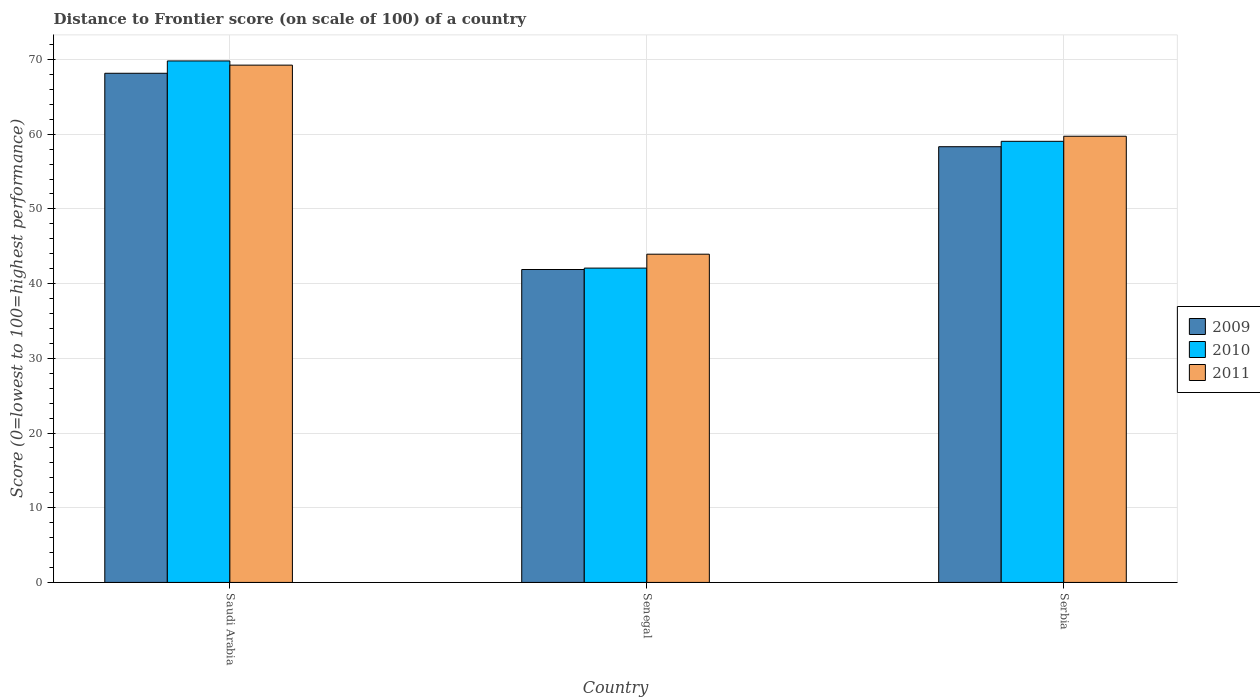How many groups of bars are there?
Offer a terse response. 3. Are the number of bars per tick equal to the number of legend labels?
Make the answer very short. Yes. Are the number of bars on each tick of the X-axis equal?
Offer a terse response. Yes. How many bars are there on the 2nd tick from the left?
Give a very brief answer. 3. How many bars are there on the 1st tick from the right?
Your answer should be very brief. 3. What is the label of the 1st group of bars from the left?
Your answer should be compact. Saudi Arabia. In how many cases, is the number of bars for a given country not equal to the number of legend labels?
Your answer should be compact. 0. What is the distance to frontier score of in 2010 in Senegal?
Provide a succinct answer. 42.08. Across all countries, what is the maximum distance to frontier score of in 2011?
Make the answer very short. 69.25. Across all countries, what is the minimum distance to frontier score of in 2009?
Make the answer very short. 41.89. In which country was the distance to frontier score of in 2009 maximum?
Provide a short and direct response. Saudi Arabia. In which country was the distance to frontier score of in 2010 minimum?
Keep it short and to the point. Senegal. What is the total distance to frontier score of in 2010 in the graph?
Your response must be concise. 170.94. What is the difference between the distance to frontier score of in 2010 in Saudi Arabia and that in Senegal?
Keep it short and to the point. 27.73. What is the difference between the distance to frontier score of in 2011 in Serbia and the distance to frontier score of in 2010 in Saudi Arabia?
Provide a short and direct response. -10.08. What is the average distance to frontier score of in 2011 per country?
Make the answer very short. 57.64. What is the difference between the distance to frontier score of of/in 2011 and distance to frontier score of of/in 2010 in Serbia?
Make the answer very short. 0.68. In how many countries, is the distance to frontier score of in 2010 greater than 36?
Ensure brevity in your answer.  3. What is the ratio of the distance to frontier score of in 2011 in Saudi Arabia to that in Serbia?
Give a very brief answer. 1.16. Is the difference between the distance to frontier score of in 2011 in Senegal and Serbia greater than the difference between the distance to frontier score of in 2010 in Senegal and Serbia?
Your response must be concise. Yes. What is the difference between the highest and the second highest distance to frontier score of in 2010?
Offer a very short reply. -16.97. What is the difference between the highest and the lowest distance to frontier score of in 2010?
Give a very brief answer. 27.73. Is the sum of the distance to frontier score of in 2011 in Saudi Arabia and Serbia greater than the maximum distance to frontier score of in 2010 across all countries?
Your response must be concise. Yes. What does the 3rd bar from the left in Serbia represents?
Your answer should be very brief. 2011. How many bars are there?
Offer a terse response. 9. Are all the bars in the graph horizontal?
Your answer should be compact. No. What is the difference between two consecutive major ticks on the Y-axis?
Ensure brevity in your answer.  10. Are the values on the major ticks of Y-axis written in scientific E-notation?
Provide a succinct answer. No. How many legend labels are there?
Your answer should be very brief. 3. How are the legend labels stacked?
Your answer should be very brief. Vertical. What is the title of the graph?
Offer a terse response. Distance to Frontier score (on scale of 100) of a country. Does "1960" appear as one of the legend labels in the graph?
Provide a short and direct response. No. What is the label or title of the X-axis?
Offer a very short reply. Country. What is the label or title of the Y-axis?
Provide a succinct answer. Score (0=lowest to 100=highest performance). What is the Score (0=lowest to 100=highest performance) of 2009 in Saudi Arabia?
Keep it short and to the point. 68.16. What is the Score (0=lowest to 100=highest performance) in 2010 in Saudi Arabia?
Ensure brevity in your answer.  69.81. What is the Score (0=lowest to 100=highest performance) in 2011 in Saudi Arabia?
Ensure brevity in your answer.  69.25. What is the Score (0=lowest to 100=highest performance) of 2009 in Senegal?
Provide a succinct answer. 41.89. What is the Score (0=lowest to 100=highest performance) in 2010 in Senegal?
Offer a terse response. 42.08. What is the Score (0=lowest to 100=highest performance) in 2011 in Senegal?
Ensure brevity in your answer.  43.94. What is the Score (0=lowest to 100=highest performance) in 2009 in Serbia?
Give a very brief answer. 58.33. What is the Score (0=lowest to 100=highest performance) of 2010 in Serbia?
Offer a terse response. 59.05. What is the Score (0=lowest to 100=highest performance) in 2011 in Serbia?
Offer a terse response. 59.73. Across all countries, what is the maximum Score (0=lowest to 100=highest performance) in 2009?
Provide a short and direct response. 68.16. Across all countries, what is the maximum Score (0=lowest to 100=highest performance) in 2010?
Make the answer very short. 69.81. Across all countries, what is the maximum Score (0=lowest to 100=highest performance) of 2011?
Your response must be concise. 69.25. Across all countries, what is the minimum Score (0=lowest to 100=highest performance) of 2009?
Keep it short and to the point. 41.89. Across all countries, what is the minimum Score (0=lowest to 100=highest performance) of 2010?
Your answer should be very brief. 42.08. Across all countries, what is the minimum Score (0=lowest to 100=highest performance) in 2011?
Make the answer very short. 43.94. What is the total Score (0=lowest to 100=highest performance) in 2009 in the graph?
Your answer should be very brief. 168.38. What is the total Score (0=lowest to 100=highest performance) in 2010 in the graph?
Keep it short and to the point. 170.94. What is the total Score (0=lowest to 100=highest performance) in 2011 in the graph?
Your answer should be compact. 172.92. What is the difference between the Score (0=lowest to 100=highest performance) in 2009 in Saudi Arabia and that in Senegal?
Provide a short and direct response. 26.27. What is the difference between the Score (0=lowest to 100=highest performance) in 2010 in Saudi Arabia and that in Senegal?
Provide a short and direct response. 27.73. What is the difference between the Score (0=lowest to 100=highest performance) in 2011 in Saudi Arabia and that in Senegal?
Your response must be concise. 25.31. What is the difference between the Score (0=lowest to 100=highest performance) of 2009 in Saudi Arabia and that in Serbia?
Ensure brevity in your answer.  9.83. What is the difference between the Score (0=lowest to 100=highest performance) in 2010 in Saudi Arabia and that in Serbia?
Give a very brief answer. 10.76. What is the difference between the Score (0=lowest to 100=highest performance) of 2011 in Saudi Arabia and that in Serbia?
Give a very brief answer. 9.52. What is the difference between the Score (0=lowest to 100=highest performance) of 2009 in Senegal and that in Serbia?
Your response must be concise. -16.44. What is the difference between the Score (0=lowest to 100=highest performance) in 2010 in Senegal and that in Serbia?
Keep it short and to the point. -16.97. What is the difference between the Score (0=lowest to 100=highest performance) of 2011 in Senegal and that in Serbia?
Give a very brief answer. -15.79. What is the difference between the Score (0=lowest to 100=highest performance) of 2009 in Saudi Arabia and the Score (0=lowest to 100=highest performance) of 2010 in Senegal?
Offer a terse response. 26.08. What is the difference between the Score (0=lowest to 100=highest performance) in 2009 in Saudi Arabia and the Score (0=lowest to 100=highest performance) in 2011 in Senegal?
Give a very brief answer. 24.22. What is the difference between the Score (0=lowest to 100=highest performance) in 2010 in Saudi Arabia and the Score (0=lowest to 100=highest performance) in 2011 in Senegal?
Your answer should be very brief. 25.87. What is the difference between the Score (0=lowest to 100=highest performance) of 2009 in Saudi Arabia and the Score (0=lowest to 100=highest performance) of 2010 in Serbia?
Offer a very short reply. 9.11. What is the difference between the Score (0=lowest to 100=highest performance) of 2009 in Saudi Arabia and the Score (0=lowest to 100=highest performance) of 2011 in Serbia?
Provide a short and direct response. 8.43. What is the difference between the Score (0=lowest to 100=highest performance) of 2010 in Saudi Arabia and the Score (0=lowest to 100=highest performance) of 2011 in Serbia?
Provide a short and direct response. 10.08. What is the difference between the Score (0=lowest to 100=highest performance) of 2009 in Senegal and the Score (0=lowest to 100=highest performance) of 2010 in Serbia?
Offer a terse response. -17.16. What is the difference between the Score (0=lowest to 100=highest performance) in 2009 in Senegal and the Score (0=lowest to 100=highest performance) in 2011 in Serbia?
Give a very brief answer. -17.84. What is the difference between the Score (0=lowest to 100=highest performance) in 2010 in Senegal and the Score (0=lowest to 100=highest performance) in 2011 in Serbia?
Your response must be concise. -17.65. What is the average Score (0=lowest to 100=highest performance) of 2009 per country?
Offer a very short reply. 56.13. What is the average Score (0=lowest to 100=highest performance) in 2010 per country?
Provide a succinct answer. 56.98. What is the average Score (0=lowest to 100=highest performance) of 2011 per country?
Provide a short and direct response. 57.64. What is the difference between the Score (0=lowest to 100=highest performance) of 2009 and Score (0=lowest to 100=highest performance) of 2010 in Saudi Arabia?
Your answer should be compact. -1.65. What is the difference between the Score (0=lowest to 100=highest performance) in 2009 and Score (0=lowest to 100=highest performance) in 2011 in Saudi Arabia?
Give a very brief answer. -1.09. What is the difference between the Score (0=lowest to 100=highest performance) of 2010 and Score (0=lowest to 100=highest performance) of 2011 in Saudi Arabia?
Give a very brief answer. 0.56. What is the difference between the Score (0=lowest to 100=highest performance) of 2009 and Score (0=lowest to 100=highest performance) of 2010 in Senegal?
Give a very brief answer. -0.19. What is the difference between the Score (0=lowest to 100=highest performance) in 2009 and Score (0=lowest to 100=highest performance) in 2011 in Senegal?
Offer a very short reply. -2.05. What is the difference between the Score (0=lowest to 100=highest performance) in 2010 and Score (0=lowest to 100=highest performance) in 2011 in Senegal?
Make the answer very short. -1.86. What is the difference between the Score (0=lowest to 100=highest performance) of 2009 and Score (0=lowest to 100=highest performance) of 2010 in Serbia?
Your answer should be very brief. -0.72. What is the difference between the Score (0=lowest to 100=highest performance) of 2010 and Score (0=lowest to 100=highest performance) of 2011 in Serbia?
Give a very brief answer. -0.68. What is the ratio of the Score (0=lowest to 100=highest performance) of 2009 in Saudi Arabia to that in Senegal?
Ensure brevity in your answer.  1.63. What is the ratio of the Score (0=lowest to 100=highest performance) of 2010 in Saudi Arabia to that in Senegal?
Your answer should be very brief. 1.66. What is the ratio of the Score (0=lowest to 100=highest performance) of 2011 in Saudi Arabia to that in Senegal?
Your answer should be very brief. 1.58. What is the ratio of the Score (0=lowest to 100=highest performance) of 2009 in Saudi Arabia to that in Serbia?
Ensure brevity in your answer.  1.17. What is the ratio of the Score (0=lowest to 100=highest performance) in 2010 in Saudi Arabia to that in Serbia?
Keep it short and to the point. 1.18. What is the ratio of the Score (0=lowest to 100=highest performance) of 2011 in Saudi Arabia to that in Serbia?
Offer a very short reply. 1.16. What is the ratio of the Score (0=lowest to 100=highest performance) in 2009 in Senegal to that in Serbia?
Offer a terse response. 0.72. What is the ratio of the Score (0=lowest to 100=highest performance) of 2010 in Senegal to that in Serbia?
Keep it short and to the point. 0.71. What is the ratio of the Score (0=lowest to 100=highest performance) in 2011 in Senegal to that in Serbia?
Ensure brevity in your answer.  0.74. What is the difference between the highest and the second highest Score (0=lowest to 100=highest performance) in 2009?
Your answer should be compact. 9.83. What is the difference between the highest and the second highest Score (0=lowest to 100=highest performance) in 2010?
Offer a very short reply. 10.76. What is the difference between the highest and the second highest Score (0=lowest to 100=highest performance) of 2011?
Your response must be concise. 9.52. What is the difference between the highest and the lowest Score (0=lowest to 100=highest performance) of 2009?
Keep it short and to the point. 26.27. What is the difference between the highest and the lowest Score (0=lowest to 100=highest performance) of 2010?
Your response must be concise. 27.73. What is the difference between the highest and the lowest Score (0=lowest to 100=highest performance) in 2011?
Your answer should be compact. 25.31. 